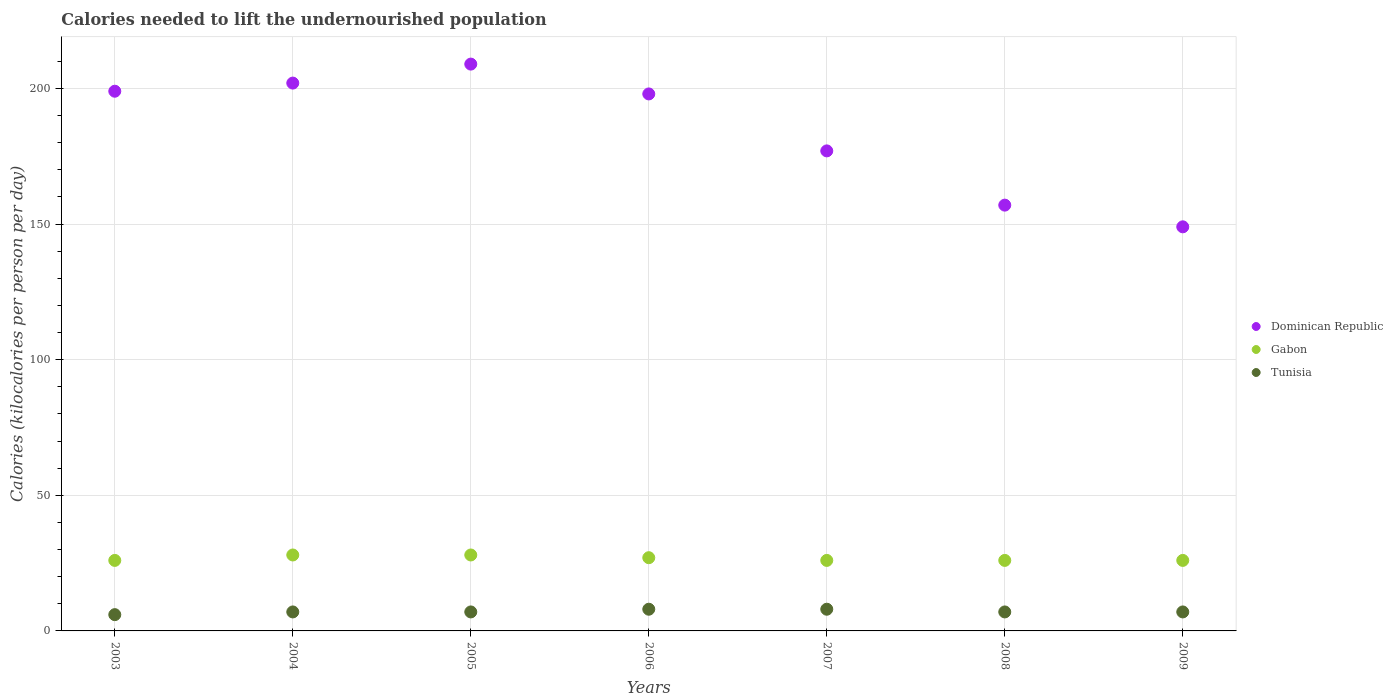How many different coloured dotlines are there?
Give a very brief answer. 3. What is the total calories needed to lift the undernourished population in Gabon in 2005?
Make the answer very short. 28. Across all years, what is the maximum total calories needed to lift the undernourished population in Dominican Republic?
Provide a short and direct response. 209. Across all years, what is the minimum total calories needed to lift the undernourished population in Dominican Republic?
Provide a succinct answer. 149. In which year was the total calories needed to lift the undernourished population in Dominican Republic maximum?
Offer a very short reply. 2005. In which year was the total calories needed to lift the undernourished population in Gabon minimum?
Give a very brief answer. 2003. What is the total total calories needed to lift the undernourished population in Gabon in the graph?
Provide a short and direct response. 187. What is the difference between the total calories needed to lift the undernourished population in Dominican Republic in 2006 and that in 2008?
Ensure brevity in your answer.  41. What is the difference between the total calories needed to lift the undernourished population in Dominican Republic in 2005 and the total calories needed to lift the undernourished population in Gabon in 2007?
Provide a short and direct response. 183. What is the average total calories needed to lift the undernourished population in Dominican Republic per year?
Your response must be concise. 184.43. In the year 2006, what is the difference between the total calories needed to lift the undernourished population in Dominican Republic and total calories needed to lift the undernourished population in Gabon?
Keep it short and to the point. 171. What is the ratio of the total calories needed to lift the undernourished population in Dominican Republic in 2004 to that in 2009?
Provide a short and direct response. 1.36. Is the difference between the total calories needed to lift the undernourished population in Dominican Republic in 2003 and 2006 greater than the difference between the total calories needed to lift the undernourished population in Gabon in 2003 and 2006?
Your response must be concise. Yes. What is the difference between the highest and the lowest total calories needed to lift the undernourished population in Gabon?
Make the answer very short. 2. Is the sum of the total calories needed to lift the undernourished population in Gabon in 2007 and 2009 greater than the maximum total calories needed to lift the undernourished population in Dominican Republic across all years?
Your answer should be compact. No. Is it the case that in every year, the sum of the total calories needed to lift the undernourished population in Tunisia and total calories needed to lift the undernourished population in Gabon  is greater than the total calories needed to lift the undernourished population in Dominican Republic?
Provide a succinct answer. No. Are the values on the major ticks of Y-axis written in scientific E-notation?
Your response must be concise. No. Does the graph contain any zero values?
Make the answer very short. No. Does the graph contain grids?
Provide a succinct answer. Yes. How many legend labels are there?
Make the answer very short. 3. What is the title of the graph?
Offer a terse response. Calories needed to lift the undernourished population. Does "Cabo Verde" appear as one of the legend labels in the graph?
Your answer should be very brief. No. What is the label or title of the Y-axis?
Offer a very short reply. Calories (kilocalories per person per day). What is the Calories (kilocalories per person per day) of Dominican Republic in 2003?
Provide a succinct answer. 199. What is the Calories (kilocalories per person per day) in Gabon in 2003?
Provide a short and direct response. 26. What is the Calories (kilocalories per person per day) of Tunisia in 2003?
Ensure brevity in your answer.  6. What is the Calories (kilocalories per person per day) of Dominican Republic in 2004?
Give a very brief answer. 202. What is the Calories (kilocalories per person per day) in Tunisia in 2004?
Your answer should be compact. 7. What is the Calories (kilocalories per person per day) of Dominican Republic in 2005?
Your answer should be very brief. 209. What is the Calories (kilocalories per person per day) in Gabon in 2005?
Make the answer very short. 28. What is the Calories (kilocalories per person per day) in Tunisia in 2005?
Provide a succinct answer. 7. What is the Calories (kilocalories per person per day) of Dominican Republic in 2006?
Offer a terse response. 198. What is the Calories (kilocalories per person per day) of Gabon in 2006?
Offer a terse response. 27. What is the Calories (kilocalories per person per day) of Dominican Republic in 2007?
Offer a terse response. 177. What is the Calories (kilocalories per person per day) of Dominican Republic in 2008?
Keep it short and to the point. 157. What is the Calories (kilocalories per person per day) of Gabon in 2008?
Provide a short and direct response. 26. What is the Calories (kilocalories per person per day) of Tunisia in 2008?
Your response must be concise. 7. What is the Calories (kilocalories per person per day) in Dominican Republic in 2009?
Make the answer very short. 149. What is the Calories (kilocalories per person per day) in Gabon in 2009?
Your answer should be very brief. 26. What is the Calories (kilocalories per person per day) in Tunisia in 2009?
Give a very brief answer. 7. Across all years, what is the maximum Calories (kilocalories per person per day) of Dominican Republic?
Provide a succinct answer. 209. Across all years, what is the maximum Calories (kilocalories per person per day) of Gabon?
Provide a succinct answer. 28. Across all years, what is the minimum Calories (kilocalories per person per day) of Dominican Republic?
Keep it short and to the point. 149. Across all years, what is the minimum Calories (kilocalories per person per day) in Gabon?
Ensure brevity in your answer.  26. What is the total Calories (kilocalories per person per day) in Dominican Republic in the graph?
Your answer should be compact. 1291. What is the total Calories (kilocalories per person per day) in Gabon in the graph?
Offer a very short reply. 187. What is the difference between the Calories (kilocalories per person per day) in Dominican Republic in 2003 and that in 2004?
Provide a succinct answer. -3. What is the difference between the Calories (kilocalories per person per day) of Dominican Republic in 2003 and that in 2005?
Your response must be concise. -10. What is the difference between the Calories (kilocalories per person per day) in Gabon in 2003 and that in 2005?
Offer a terse response. -2. What is the difference between the Calories (kilocalories per person per day) of Tunisia in 2003 and that in 2005?
Your answer should be very brief. -1. What is the difference between the Calories (kilocalories per person per day) in Tunisia in 2003 and that in 2006?
Offer a very short reply. -2. What is the difference between the Calories (kilocalories per person per day) of Gabon in 2003 and that in 2007?
Offer a terse response. 0. What is the difference between the Calories (kilocalories per person per day) in Gabon in 2003 and that in 2008?
Offer a very short reply. 0. What is the difference between the Calories (kilocalories per person per day) of Tunisia in 2003 and that in 2008?
Your answer should be compact. -1. What is the difference between the Calories (kilocalories per person per day) in Dominican Republic in 2003 and that in 2009?
Your answer should be very brief. 50. What is the difference between the Calories (kilocalories per person per day) of Gabon in 2003 and that in 2009?
Your answer should be compact. 0. What is the difference between the Calories (kilocalories per person per day) of Dominican Republic in 2004 and that in 2005?
Ensure brevity in your answer.  -7. What is the difference between the Calories (kilocalories per person per day) in Tunisia in 2004 and that in 2005?
Your answer should be very brief. 0. What is the difference between the Calories (kilocalories per person per day) in Dominican Republic in 2004 and that in 2006?
Keep it short and to the point. 4. What is the difference between the Calories (kilocalories per person per day) in Gabon in 2004 and that in 2006?
Make the answer very short. 1. What is the difference between the Calories (kilocalories per person per day) in Dominican Republic in 2004 and that in 2007?
Offer a very short reply. 25. What is the difference between the Calories (kilocalories per person per day) in Gabon in 2004 and that in 2007?
Ensure brevity in your answer.  2. What is the difference between the Calories (kilocalories per person per day) of Dominican Republic in 2004 and that in 2009?
Give a very brief answer. 53. What is the difference between the Calories (kilocalories per person per day) in Tunisia in 2004 and that in 2009?
Make the answer very short. 0. What is the difference between the Calories (kilocalories per person per day) of Gabon in 2005 and that in 2006?
Your answer should be compact. 1. What is the difference between the Calories (kilocalories per person per day) of Tunisia in 2005 and that in 2006?
Give a very brief answer. -1. What is the difference between the Calories (kilocalories per person per day) in Dominican Republic in 2005 and that in 2007?
Offer a very short reply. 32. What is the difference between the Calories (kilocalories per person per day) of Gabon in 2005 and that in 2007?
Offer a very short reply. 2. What is the difference between the Calories (kilocalories per person per day) in Tunisia in 2005 and that in 2008?
Provide a short and direct response. 0. What is the difference between the Calories (kilocalories per person per day) in Dominican Republic in 2005 and that in 2009?
Ensure brevity in your answer.  60. What is the difference between the Calories (kilocalories per person per day) in Dominican Republic in 2006 and that in 2008?
Your answer should be very brief. 41. What is the difference between the Calories (kilocalories per person per day) of Gabon in 2006 and that in 2008?
Offer a very short reply. 1. What is the difference between the Calories (kilocalories per person per day) of Dominican Republic in 2006 and that in 2009?
Make the answer very short. 49. What is the difference between the Calories (kilocalories per person per day) in Tunisia in 2006 and that in 2009?
Ensure brevity in your answer.  1. What is the difference between the Calories (kilocalories per person per day) of Tunisia in 2007 and that in 2008?
Provide a short and direct response. 1. What is the difference between the Calories (kilocalories per person per day) of Dominican Republic in 2007 and that in 2009?
Your answer should be compact. 28. What is the difference between the Calories (kilocalories per person per day) in Dominican Republic in 2008 and that in 2009?
Offer a terse response. 8. What is the difference between the Calories (kilocalories per person per day) of Gabon in 2008 and that in 2009?
Provide a succinct answer. 0. What is the difference between the Calories (kilocalories per person per day) of Tunisia in 2008 and that in 2009?
Provide a succinct answer. 0. What is the difference between the Calories (kilocalories per person per day) in Dominican Republic in 2003 and the Calories (kilocalories per person per day) in Gabon in 2004?
Give a very brief answer. 171. What is the difference between the Calories (kilocalories per person per day) of Dominican Republic in 2003 and the Calories (kilocalories per person per day) of Tunisia in 2004?
Your answer should be very brief. 192. What is the difference between the Calories (kilocalories per person per day) of Dominican Republic in 2003 and the Calories (kilocalories per person per day) of Gabon in 2005?
Ensure brevity in your answer.  171. What is the difference between the Calories (kilocalories per person per day) in Dominican Republic in 2003 and the Calories (kilocalories per person per day) in Tunisia in 2005?
Your response must be concise. 192. What is the difference between the Calories (kilocalories per person per day) of Gabon in 2003 and the Calories (kilocalories per person per day) of Tunisia in 2005?
Keep it short and to the point. 19. What is the difference between the Calories (kilocalories per person per day) in Dominican Republic in 2003 and the Calories (kilocalories per person per day) in Gabon in 2006?
Offer a very short reply. 172. What is the difference between the Calories (kilocalories per person per day) in Dominican Republic in 2003 and the Calories (kilocalories per person per day) in Tunisia in 2006?
Provide a short and direct response. 191. What is the difference between the Calories (kilocalories per person per day) of Dominican Republic in 2003 and the Calories (kilocalories per person per day) of Gabon in 2007?
Provide a succinct answer. 173. What is the difference between the Calories (kilocalories per person per day) in Dominican Republic in 2003 and the Calories (kilocalories per person per day) in Tunisia in 2007?
Keep it short and to the point. 191. What is the difference between the Calories (kilocalories per person per day) of Dominican Republic in 2003 and the Calories (kilocalories per person per day) of Gabon in 2008?
Give a very brief answer. 173. What is the difference between the Calories (kilocalories per person per day) of Dominican Republic in 2003 and the Calories (kilocalories per person per day) of Tunisia in 2008?
Ensure brevity in your answer.  192. What is the difference between the Calories (kilocalories per person per day) of Gabon in 2003 and the Calories (kilocalories per person per day) of Tunisia in 2008?
Provide a succinct answer. 19. What is the difference between the Calories (kilocalories per person per day) of Dominican Republic in 2003 and the Calories (kilocalories per person per day) of Gabon in 2009?
Your response must be concise. 173. What is the difference between the Calories (kilocalories per person per day) in Dominican Republic in 2003 and the Calories (kilocalories per person per day) in Tunisia in 2009?
Make the answer very short. 192. What is the difference between the Calories (kilocalories per person per day) in Gabon in 2003 and the Calories (kilocalories per person per day) in Tunisia in 2009?
Provide a succinct answer. 19. What is the difference between the Calories (kilocalories per person per day) in Dominican Republic in 2004 and the Calories (kilocalories per person per day) in Gabon in 2005?
Offer a terse response. 174. What is the difference between the Calories (kilocalories per person per day) of Dominican Republic in 2004 and the Calories (kilocalories per person per day) of Tunisia in 2005?
Keep it short and to the point. 195. What is the difference between the Calories (kilocalories per person per day) of Dominican Republic in 2004 and the Calories (kilocalories per person per day) of Gabon in 2006?
Your response must be concise. 175. What is the difference between the Calories (kilocalories per person per day) of Dominican Republic in 2004 and the Calories (kilocalories per person per day) of Tunisia in 2006?
Offer a very short reply. 194. What is the difference between the Calories (kilocalories per person per day) of Gabon in 2004 and the Calories (kilocalories per person per day) of Tunisia in 2006?
Your answer should be compact. 20. What is the difference between the Calories (kilocalories per person per day) of Dominican Republic in 2004 and the Calories (kilocalories per person per day) of Gabon in 2007?
Your response must be concise. 176. What is the difference between the Calories (kilocalories per person per day) in Dominican Republic in 2004 and the Calories (kilocalories per person per day) in Tunisia in 2007?
Your answer should be very brief. 194. What is the difference between the Calories (kilocalories per person per day) of Gabon in 2004 and the Calories (kilocalories per person per day) of Tunisia in 2007?
Give a very brief answer. 20. What is the difference between the Calories (kilocalories per person per day) in Dominican Republic in 2004 and the Calories (kilocalories per person per day) in Gabon in 2008?
Your answer should be very brief. 176. What is the difference between the Calories (kilocalories per person per day) in Dominican Republic in 2004 and the Calories (kilocalories per person per day) in Tunisia in 2008?
Make the answer very short. 195. What is the difference between the Calories (kilocalories per person per day) in Dominican Republic in 2004 and the Calories (kilocalories per person per day) in Gabon in 2009?
Your response must be concise. 176. What is the difference between the Calories (kilocalories per person per day) in Dominican Republic in 2004 and the Calories (kilocalories per person per day) in Tunisia in 2009?
Keep it short and to the point. 195. What is the difference between the Calories (kilocalories per person per day) in Dominican Republic in 2005 and the Calories (kilocalories per person per day) in Gabon in 2006?
Your answer should be compact. 182. What is the difference between the Calories (kilocalories per person per day) in Dominican Republic in 2005 and the Calories (kilocalories per person per day) in Tunisia in 2006?
Offer a very short reply. 201. What is the difference between the Calories (kilocalories per person per day) of Dominican Republic in 2005 and the Calories (kilocalories per person per day) of Gabon in 2007?
Keep it short and to the point. 183. What is the difference between the Calories (kilocalories per person per day) in Dominican Republic in 2005 and the Calories (kilocalories per person per day) in Tunisia in 2007?
Keep it short and to the point. 201. What is the difference between the Calories (kilocalories per person per day) in Dominican Republic in 2005 and the Calories (kilocalories per person per day) in Gabon in 2008?
Ensure brevity in your answer.  183. What is the difference between the Calories (kilocalories per person per day) in Dominican Republic in 2005 and the Calories (kilocalories per person per day) in Tunisia in 2008?
Give a very brief answer. 202. What is the difference between the Calories (kilocalories per person per day) in Dominican Republic in 2005 and the Calories (kilocalories per person per day) in Gabon in 2009?
Offer a very short reply. 183. What is the difference between the Calories (kilocalories per person per day) in Dominican Republic in 2005 and the Calories (kilocalories per person per day) in Tunisia in 2009?
Your response must be concise. 202. What is the difference between the Calories (kilocalories per person per day) in Dominican Republic in 2006 and the Calories (kilocalories per person per day) in Gabon in 2007?
Offer a very short reply. 172. What is the difference between the Calories (kilocalories per person per day) in Dominican Republic in 2006 and the Calories (kilocalories per person per day) in Tunisia in 2007?
Make the answer very short. 190. What is the difference between the Calories (kilocalories per person per day) in Gabon in 2006 and the Calories (kilocalories per person per day) in Tunisia in 2007?
Your response must be concise. 19. What is the difference between the Calories (kilocalories per person per day) in Dominican Republic in 2006 and the Calories (kilocalories per person per day) in Gabon in 2008?
Your response must be concise. 172. What is the difference between the Calories (kilocalories per person per day) in Dominican Republic in 2006 and the Calories (kilocalories per person per day) in Tunisia in 2008?
Keep it short and to the point. 191. What is the difference between the Calories (kilocalories per person per day) of Gabon in 2006 and the Calories (kilocalories per person per day) of Tunisia in 2008?
Your response must be concise. 20. What is the difference between the Calories (kilocalories per person per day) of Dominican Republic in 2006 and the Calories (kilocalories per person per day) of Gabon in 2009?
Keep it short and to the point. 172. What is the difference between the Calories (kilocalories per person per day) in Dominican Republic in 2006 and the Calories (kilocalories per person per day) in Tunisia in 2009?
Your answer should be very brief. 191. What is the difference between the Calories (kilocalories per person per day) of Dominican Republic in 2007 and the Calories (kilocalories per person per day) of Gabon in 2008?
Provide a succinct answer. 151. What is the difference between the Calories (kilocalories per person per day) in Dominican Republic in 2007 and the Calories (kilocalories per person per day) in Tunisia in 2008?
Your answer should be very brief. 170. What is the difference between the Calories (kilocalories per person per day) in Dominican Republic in 2007 and the Calories (kilocalories per person per day) in Gabon in 2009?
Offer a terse response. 151. What is the difference between the Calories (kilocalories per person per day) of Dominican Republic in 2007 and the Calories (kilocalories per person per day) of Tunisia in 2009?
Your answer should be compact. 170. What is the difference between the Calories (kilocalories per person per day) in Dominican Republic in 2008 and the Calories (kilocalories per person per day) in Gabon in 2009?
Offer a very short reply. 131. What is the difference between the Calories (kilocalories per person per day) of Dominican Republic in 2008 and the Calories (kilocalories per person per day) of Tunisia in 2009?
Your answer should be compact. 150. What is the average Calories (kilocalories per person per day) in Dominican Republic per year?
Make the answer very short. 184.43. What is the average Calories (kilocalories per person per day) of Gabon per year?
Offer a terse response. 26.71. What is the average Calories (kilocalories per person per day) in Tunisia per year?
Your answer should be compact. 7.14. In the year 2003, what is the difference between the Calories (kilocalories per person per day) in Dominican Republic and Calories (kilocalories per person per day) in Gabon?
Make the answer very short. 173. In the year 2003, what is the difference between the Calories (kilocalories per person per day) of Dominican Republic and Calories (kilocalories per person per day) of Tunisia?
Your answer should be very brief. 193. In the year 2003, what is the difference between the Calories (kilocalories per person per day) of Gabon and Calories (kilocalories per person per day) of Tunisia?
Make the answer very short. 20. In the year 2004, what is the difference between the Calories (kilocalories per person per day) of Dominican Republic and Calories (kilocalories per person per day) of Gabon?
Ensure brevity in your answer.  174. In the year 2004, what is the difference between the Calories (kilocalories per person per day) of Dominican Republic and Calories (kilocalories per person per day) of Tunisia?
Provide a succinct answer. 195. In the year 2005, what is the difference between the Calories (kilocalories per person per day) of Dominican Republic and Calories (kilocalories per person per day) of Gabon?
Offer a terse response. 181. In the year 2005, what is the difference between the Calories (kilocalories per person per day) of Dominican Republic and Calories (kilocalories per person per day) of Tunisia?
Offer a very short reply. 202. In the year 2006, what is the difference between the Calories (kilocalories per person per day) of Dominican Republic and Calories (kilocalories per person per day) of Gabon?
Offer a terse response. 171. In the year 2006, what is the difference between the Calories (kilocalories per person per day) of Dominican Republic and Calories (kilocalories per person per day) of Tunisia?
Your answer should be compact. 190. In the year 2006, what is the difference between the Calories (kilocalories per person per day) in Gabon and Calories (kilocalories per person per day) in Tunisia?
Offer a very short reply. 19. In the year 2007, what is the difference between the Calories (kilocalories per person per day) in Dominican Republic and Calories (kilocalories per person per day) in Gabon?
Offer a terse response. 151. In the year 2007, what is the difference between the Calories (kilocalories per person per day) of Dominican Republic and Calories (kilocalories per person per day) of Tunisia?
Keep it short and to the point. 169. In the year 2007, what is the difference between the Calories (kilocalories per person per day) of Gabon and Calories (kilocalories per person per day) of Tunisia?
Keep it short and to the point. 18. In the year 2008, what is the difference between the Calories (kilocalories per person per day) in Dominican Republic and Calories (kilocalories per person per day) in Gabon?
Give a very brief answer. 131. In the year 2008, what is the difference between the Calories (kilocalories per person per day) of Dominican Republic and Calories (kilocalories per person per day) of Tunisia?
Your answer should be very brief. 150. In the year 2008, what is the difference between the Calories (kilocalories per person per day) of Gabon and Calories (kilocalories per person per day) of Tunisia?
Give a very brief answer. 19. In the year 2009, what is the difference between the Calories (kilocalories per person per day) of Dominican Republic and Calories (kilocalories per person per day) of Gabon?
Make the answer very short. 123. In the year 2009, what is the difference between the Calories (kilocalories per person per day) in Dominican Republic and Calories (kilocalories per person per day) in Tunisia?
Your answer should be very brief. 142. What is the ratio of the Calories (kilocalories per person per day) in Dominican Republic in 2003 to that in 2004?
Offer a very short reply. 0.99. What is the ratio of the Calories (kilocalories per person per day) in Gabon in 2003 to that in 2004?
Offer a terse response. 0.93. What is the ratio of the Calories (kilocalories per person per day) of Dominican Republic in 2003 to that in 2005?
Offer a terse response. 0.95. What is the ratio of the Calories (kilocalories per person per day) in Tunisia in 2003 to that in 2005?
Ensure brevity in your answer.  0.86. What is the ratio of the Calories (kilocalories per person per day) in Dominican Republic in 2003 to that in 2006?
Make the answer very short. 1.01. What is the ratio of the Calories (kilocalories per person per day) in Gabon in 2003 to that in 2006?
Provide a succinct answer. 0.96. What is the ratio of the Calories (kilocalories per person per day) of Tunisia in 2003 to that in 2006?
Your answer should be very brief. 0.75. What is the ratio of the Calories (kilocalories per person per day) of Dominican Republic in 2003 to that in 2007?
Provide a short and direct response. 1.12. What is the ratio of the Calories (kilocalories per person per day) of Gabon in 2003 to that in 2007?
Ensure brevity in your answer.  1. What is the ratio of the Calories (kilocalories per person per day) of Dominican Republic in 2003 to that in 2008?
Keep it short and to the point. 1.27. What is the ratio of the Calories (kilocalories per person per day) in Gabon in 2003 to that in 2008?
Provide a short and direct response. 1. What is the ratio of the Calories (kilocalories per person per day) in Tunisia in 2003 to that in 2008?
Your answer should be very brief. 0.86. What is the ratio of the Calories (kilocalories per person per day) in Dominican Republic in 2003 to that in 2009?
Make the answer very short. 1.34. What is the ratio of the Calories (kilocalories per person per day) in Gabon in 2003 to that in 2009?
Your response must be concise. 1. What is the ratio of the Calories (kilocalories per person per day) of Dominican Republic in 2004 to that in 2005?
Provide a short and direct response. 0.97. What is the ratio of the Calories (kilocalories per person per day) of Dominican Republic in 2004 to that in 2006?
Make the answer very short. 1.02. What is the ratio of the Calories (kilocalories per person per day) of Dominican Republic in 2004 to that in 2007?
Your response must be concise. 1.14. What is the ratio of the Calories (kilocalories per person per day) in Gabon in 2004 to that in 2007?
Provide a succinct answer. 1.08. What is the ratio of the Calories (kilocalories per person per day) in Dominican Republic in 2004 to that in 2008?
Offer a terse response. 1.29. What is the ratio of the Calories (kilocalories per person per day) of Gabon in 2004 to that in 2008?
Keep it short and to the point. 1.08. What is the ratio of the Calories (kilocalories per person per day) of Dominican Republic in 2004 to that in 2009?
Offer a very short reply. 1.36. What is the ratio of the Calories (kilocalories per person per day) in Tunisia in 2004 to that in 2009?
Ensure brevity in your answer.  1. What is the ratio of the Calories (kilocalories per person per day) in Dominican Republic in 2005 to that in 2006?
Your answer should be compact. 1.06. What is the ratio of the Calories (kilocalories per person per day) of Gabon in 2005 to that in 2006?
Give a very brief answer. 1.04. What is the ratio of the Calories (kilocalories per person per day) in Dominican Republic in 2005 to that in 2007?
Offer a terse response. 1.18. What is the ratio of the Calories (kilocalories per person per day) of Gabon in 2005 to that in 2007?
Your answer should be compact. 1.08. What is the ratio of the Calories (kilocalories per person per day) in Tunisia in 2005 to that in 2007?
Offer a very short reply. 0.88. What is the ratio of the Calories (kilocalories per person per day) of Dominican Republic in 2005 to that in 2008?
Provide a succinct answer. 1.33. What is the ratio of the Calories (kilocalories per person per day) of Gabon in 2005 to that in 2008?
Keep it short and to the point. 1.08. What is the ratio of the Calories (kilocalories per person per day) in Dominican Republic in 2005 to that in 2009?
Provide a short and direct response. 1.4. What is the ratio of the Calories (kilocalories per person per day) of Dominican Republic in 2006 to that in 2007?
Provide a succinct answer. 1.12. What is the ratio of the Calories (kilocalories per person per day) in Dominican Republic in 2006 to that in 2008?
Ensure brevity in your answer.  1.26. What is the ratio of the Calories (kilocalories per person per day) in Gabon in 2006 to that in 2008?
Provide a short and direct response. 1.04. What is the ratio of the Calories (kilocalories per person per day) of Tunisia in 2006 to that in 2008?
Offer a terse response. 1.14. What is the ratio of the Calories (kilocalories per person per day) of Dominican Republic in 2006 to that in 2009?
Keep it short and to the point. 1.33. What is the ratio of the Calories (kilocalories per person per day) of Tunisia in 2006 to that in 2009?
Make the answer very short. 1.14. What is the ratio of the Calories (kilocalories per person per day) in Dominican Republic in 2007 to that in 2008?
Provide a short and direct response. 1.13. What is the ratio of the Calories (kilocalories per person per day) in Tunisia in 2007 to that in 2008?
Make the answer very short. 1.14. What is the ratio of the Calories (kilocalories per person per day) of Dominican Republic in 2007 to that in 2009?
Your answer should be compact. 1.19. What is the ratio of the Calories (kilocalories per person per day) of Gabon in 2007 to that in 2009?
Offer a very short reply. 1. What is the ratio of the Calories (kilocalories per person per day) in Dominican Republic in 2008 to that in 2009?
Offer a terse response. 1.05. What is the ratio of the Calories (kilocalories per person per day) of Tunisia in 2008 to that in 2009?
Make the answer very short. 1. What is the difference between the highest and the second highest Calories (kilocalories per person per day) in Dominican Republic?
Make the answer very short. 7. What is the difference between the highest and the second highest Calories (kilocalories per person per day) of Gabon?
Provide a succinct answer. 0. What is the difference between the highest and the second highest Calories (kilocalories per person per day) in Tunisia?
Provide a short and direct response. 0. What is the difference between the highest and the lowest Calories (kilocalories per person per day) of Tunisia?
Offer a terse response. 2. 